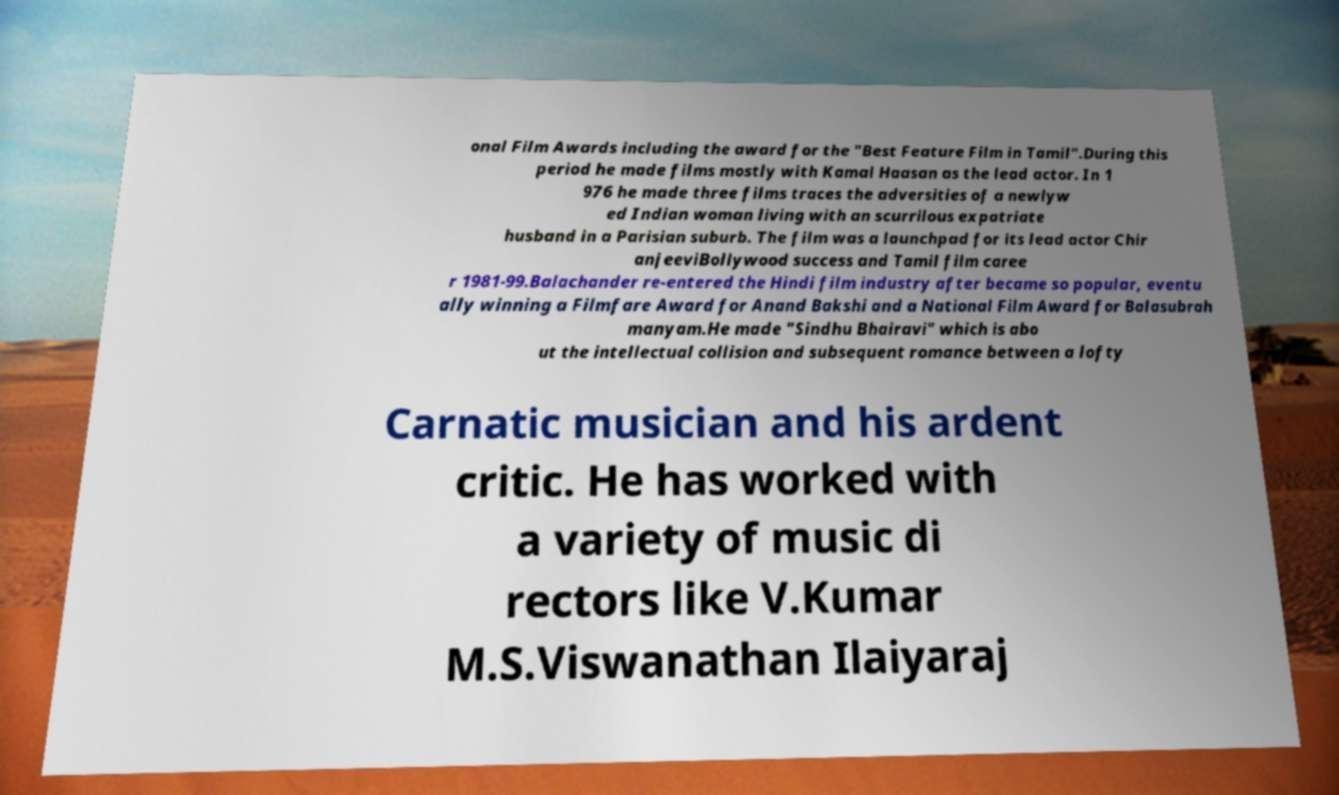For documentation purposes, I need the text within this image transcribed. Could you provide that? onal Film Awards including the award for the "Best Feature Film in Tamil".During this period he made films mostly with Kamal Haasan as the lead actor. In 1 976 he made three films traces the adversities of a newlyw ed Indian woman living with an scurrilous expatriate husband in a Parisian suburb. The film was a launchpad for its lead actor Chir anjeeviBollywood success and Tamil film caree r 1981-99.Balachander re-entered the Hindi film industry after became so popular, eventu ally winning a Filmfare Award for Anand Bakshi and a National Film Award for Balasubrah manyam.He made "Sindhu Bhairavi" which is abo ut the intellectual collision and subsequent romance between a lofty Carnatic musician and his ardent critic. He has worked with a variety of music di rectors like V.Kumar M.S.Viswanathan Ilaiyaraj 